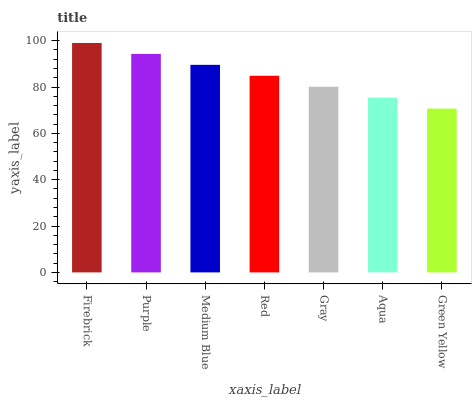Is Green Yellow the minimum?
Answer yes or no. Yes. Is Firebrick the maximum?
Answer yes or no. Yes. Is Purple the minimum?
Answer yes or no. No. Is Purple the maximum?
Answer yes or no. No. Is Firebrick greater than Purple?
Answer yes or no. Yes. Is Purple less than Firebrick?
Answer yes or no. Yes. Is Purple greater than Firebrick?
Answer yes or no. No. Is Firebrick less than Purple?
Answer yes or no. No. Is Red the high median?
Answer yes or no. Yes. Is Red the low median?
Answer yes or no. Yes. Is Green Yellow the high median?
Answer yes or no. No. Is Green Yellow the low median?
Answer yes or no. No. 